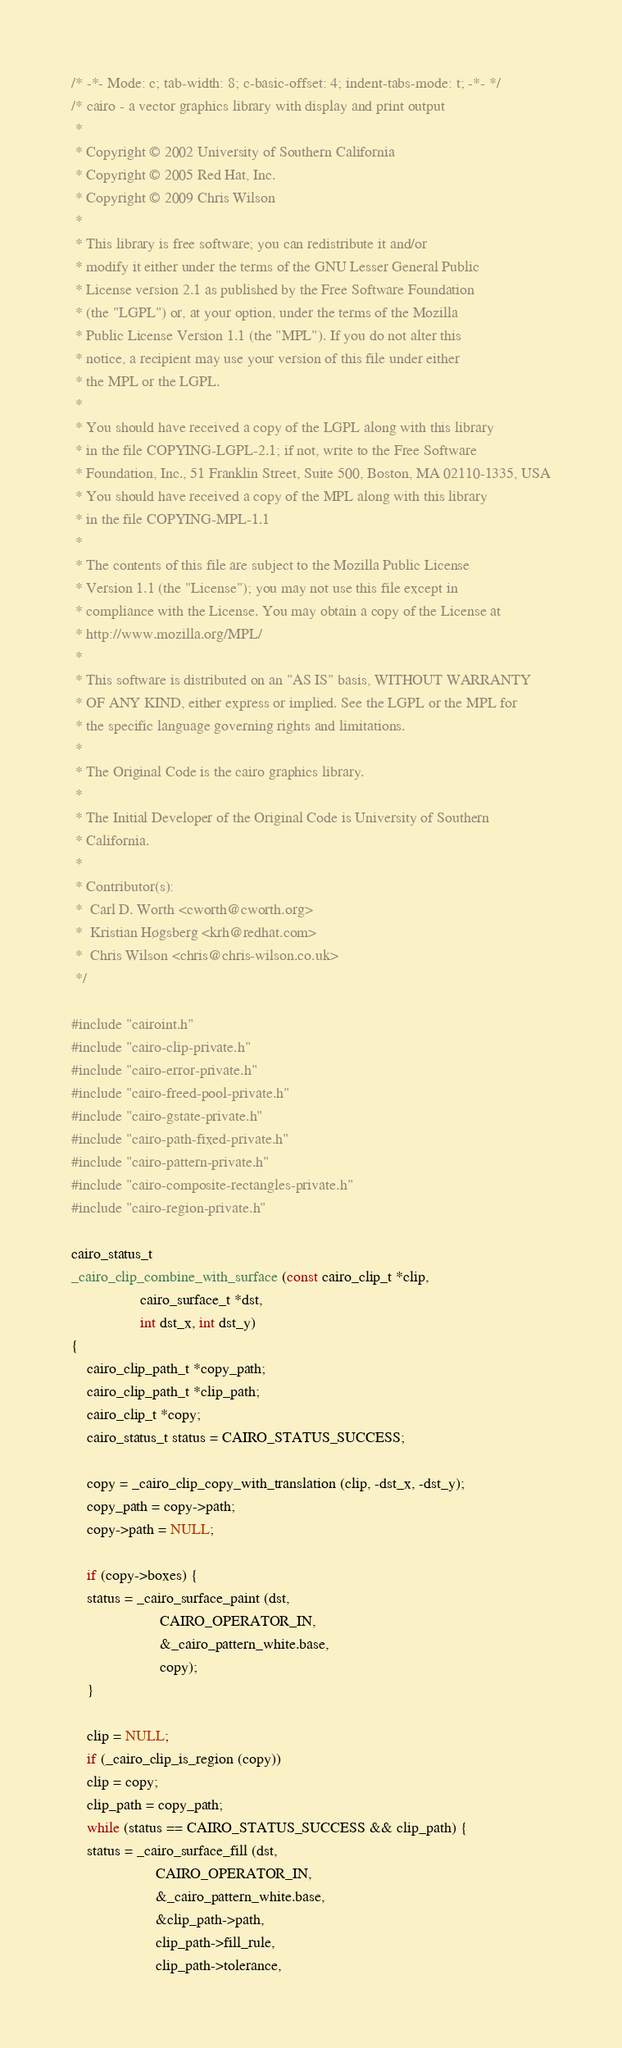<code> <loc_0><loc_0><loc_500><loc_500><_C_>/* -*- Mode: c; tab-width: 8; c-basic-offset: 4; indent-tabs-mode: t; -*- */
/* cairo - a vector graphics library with display and print output
 *
 * Copyright © 2002 University of Southern California
 * Copyright © 2005 Red Hat, Inc.
 * Copyright © 2009 Chris Wilson
 *
 * This library is free software; you can redistribute it and/or
 * modify it either under the terms of the GNU Lesser General Public
 * License version 2.1 as published by the Free Software Foundation
 * (the "LGPL") or, at your option, under the terms of the Mozilla
 * Public License Version 1.1 (the "MPL"). If you do not alter this
 * notice, a recipient may use your version of this file under either
 * the MPL or the LGPL.
 *
 * You should have received a copy of the LGPL along with this library
 * in the file COPYING-LGPL-2.1; if not, write to the Free Software
 * Foundation, Inc., 51 Franklin Street, Suite 500, Boston, MA 02110-1335, USA
 * You should have received a copy of the MPL along with this library
 * in the file COPYING-MPL-1.1
 *
 * The contents of this file are subject to the Mozilla Public License
 * Version 1.1 (the "License"); you may not use this file except in
 * compliance with the License. You may obtain a copy of the License at
 * http://www.mozilla.org/MPL/
 *
 * This software is distributed on an "AS IS" basis, WITHOUT WARRANTY
 * OF ANY KIND, either express or implied. See the LGPL or the MPL for
 * the specific language governing rights and limitations.
 *
 * The Original Code is the cairo graphics library.
 *
 * The Initial Developer of the Original Code is University of Southern
 * California.
 *
 * Contributor(s):
 *	Carl D. Worth <cworth@cworth.org>
 *	Kristian Høgsberg <krh@redhat.com>
 *	Chris Wilson <chris@chris-wilson.co.uk>
 */

#include "cairoint.h"
#include "cairo-clip-private.h"
#include "cairo-error-private.h"
#include "cairo-freed-pool-private.h"
#include "cairo-gstate-private.h"
#include "cairo-path-fixed-private.h"
#include "cairo-pattern-private.h"
#include "cairo-composite-rectangles-private.h"
#include "cairo-region-private.h"

cairo_status_t
_cairo_clip_combine_with_surface (const cairo_clip_t *clip,
				  cairo_surface_t *dst,
				  int dst_x, int dst_y)
{
    cairo_clip_path_t *copy_path;
    cairo_clip_path_t *clip_path;
    cairo_clip_t *copy;
    cairo_status_t status = CAIRO_STATUS_SUCCESS;

    copy = _cairo_clip_copy_with_translation (clip, -dst_x, -dst_y);
    copy_path = copy->path;
    copy->path = NULL;

    if (copy->boxes) {
	status = _cairo_surface_paint (dst,
				       CAIRO_OPERATOR_IN,
				       &_cairo_pattern_white.base,
				       copy);
    }

    clip = NULL;
    if (_cairo_clip_is_region (copy))
	clip = copy;
    clip_path = copy_path;
    while (status == CAIRO_STATUS_SUCCESS && clip_path) {
	status = _cairo_surface_fill (dst,
				      CAIRO_OPERATOR_IN,
				      &_cairo_pattern_white.base,
				      &clip_path->path,
				      clip_path->fill_rule,
				      clip_path->tolerance,</code> 